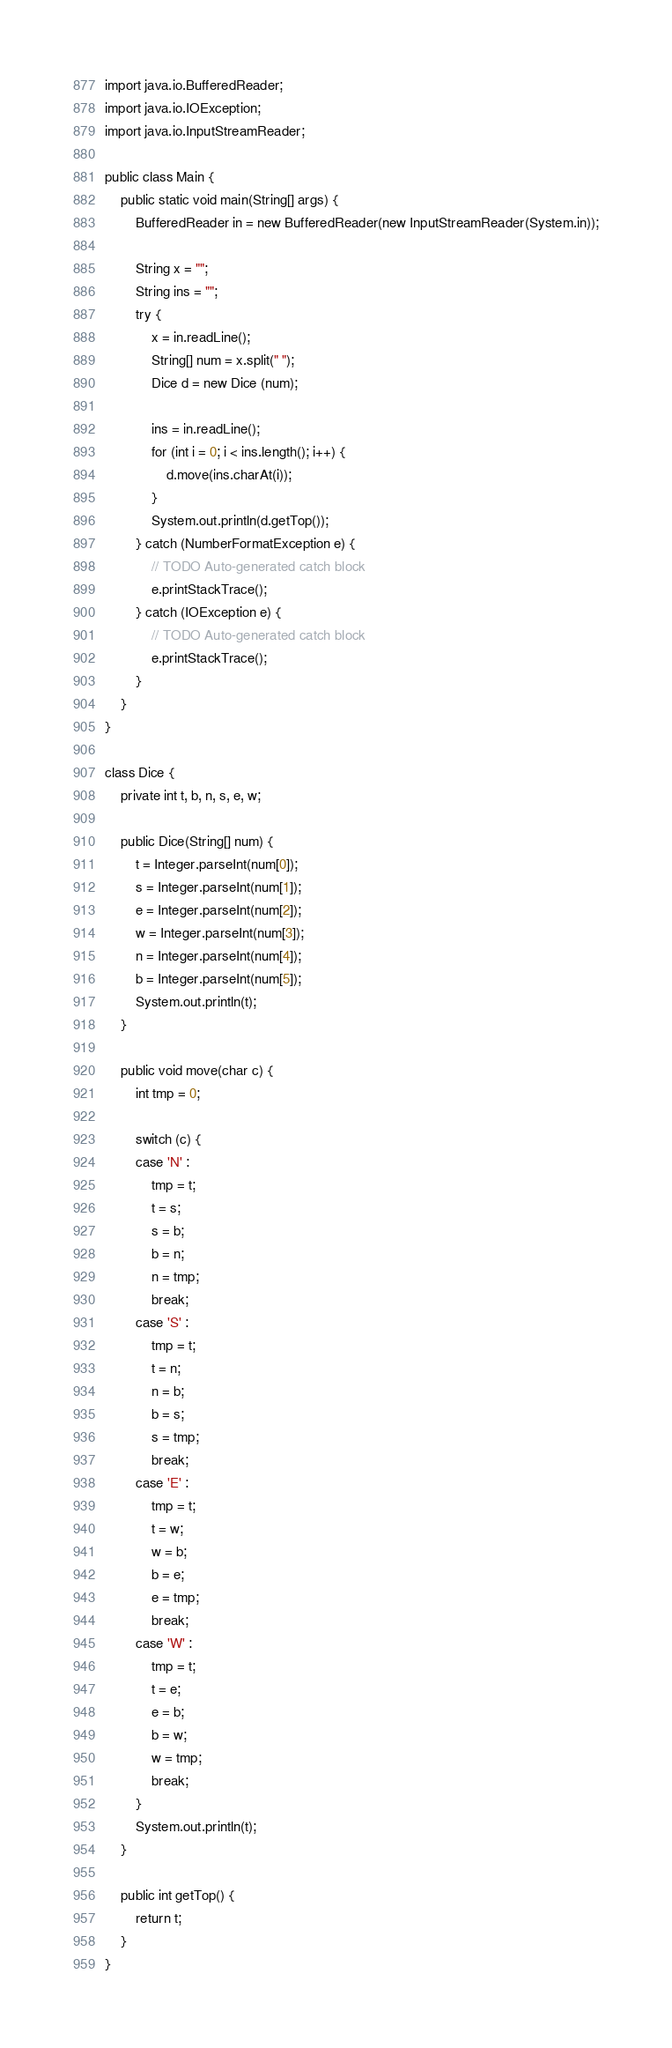Convert code to text. <code><loc_0><loc_0><loc_500><loc_500><_Java_>import java.io.BufferedReader;
import java.io.IOException;
import java.io.InputStreamReader;

public class Main {
	public static void main(String[] args) {
		BufferedReader in = new BufferedReader(new InputStreamReader(System.in));
	    
		String x = "";
		String ins = "";
		try {
			x = in.readLine();
			String[] num = x.split(" ");
			Dice d = new Dice (num);

			ins = in.readLine();
			for (int i = 0; i < ins.length(); i++) {
				d.move(ins.charAt(i));
			}
			System.out.println(d.getTop());
		} catch (NumberFormatException e) {
			// TODO Auto-generated catch block
			e.printStackTrace();
		} catch (IOException e) {
			// TODO Auto-generated catch block
			e.printStackTrace();
		}
	}
}

class Dice {
	private int t, b, n, s, e, w;
	
	public Dice(String[] num) {
		t = Integer.parseInt(num[0]);
		s = Integer.parseInt(num[1]);
		e = Integer.parseInt(num[2]);
		w = Integer.parseInt(num[3]);
		n = Integer.parseInt(num[4]);
		b = Integer.parseInt(num[5]);
		System.out.println(t);
	}
	
	public void move(char c) {
		int tmp = 0;
		
		switch (c) {
		case 'N' :
			tmp = t;
			t = s;
			s = b;
			b = n;
			n = tmp;
			break;
		case 'S' :
			tmp = t;
			t = n;
			n = b;
			b = s;
			s = tmp;
			break;
		case 'E' :
			tmp = t;
			t = w;
			w = b;
			b = e;
			e = tmp;
			break;
		case 'W' :
			tmp = t;
			t = e;
			e = b;
			b = w;
			w = tmp;
			break;
		}
		System.out.println(t);
	}
	
	public int getTop() {
		return t;
	}
}</code> 